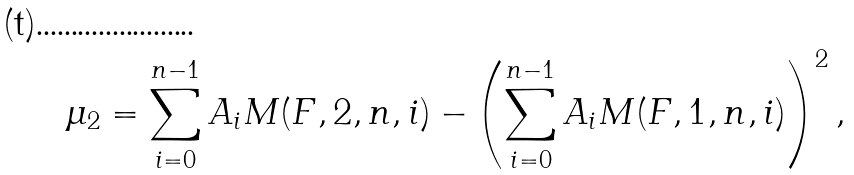Convert formula to latex. <formula><loc_0><loc_0><loc_500><loc_500>\mu _ { 2 } = \sum _ { i = 0 } ^ { n - 1 } A _ { i } M ( F , 2 , n , i ) - \left ( \sum _ { i = 0 } ^ { n - 1 } A _ { i } M ( F , 1 , n , i ) \right ) ^ { 2 } ,</formula> 